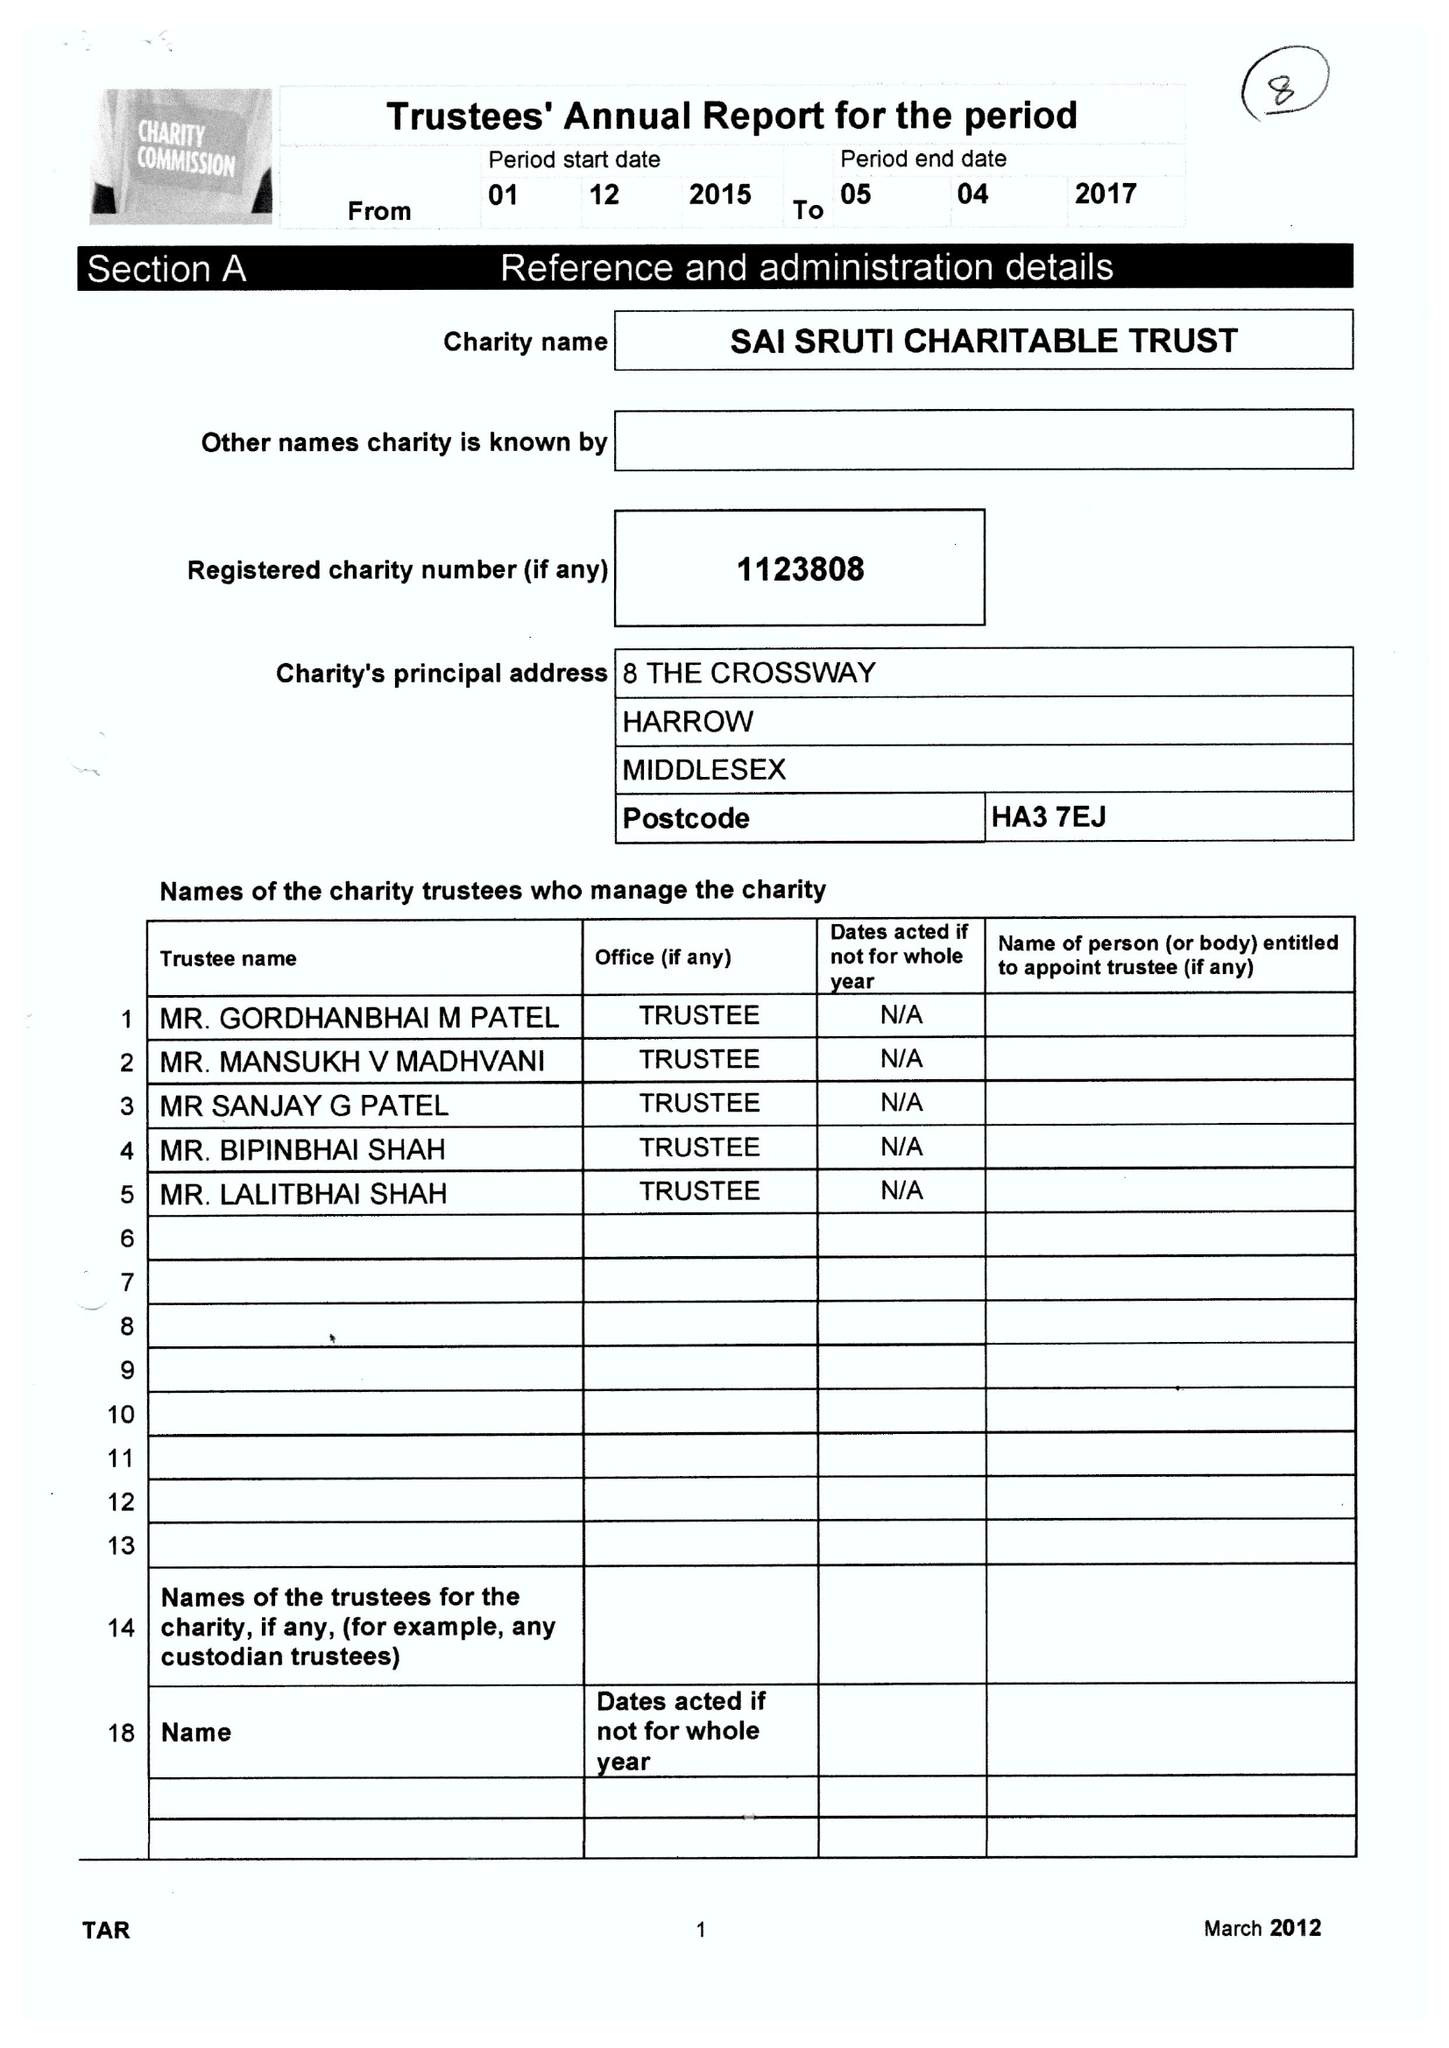What is the value for the income_annually_in_british_pounds?
Answer the question using a single word or phrase. 113163.00 